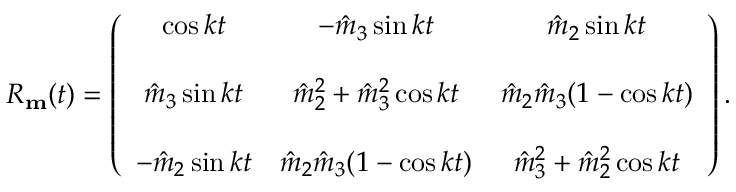<formula> <loc_0><loc_0><loc_500><loc_500>\begin{array} { r } { R _ { m } ( t ) = \left ( \begin{array} { c c c } { \cos k t } & { - \hat { m } _ { 3 } \sin k t } & { \hat { m } _ { 2 } \sin k t } \\ { \hat { m } _ { 3 } \sin k t } & { \hat { m } _ { 2 } ^ { 2 } + \hat { m } _ { 3 } ^ { 2 } \cos k t } & { \hat { m } _ { 2 } \hat { m } _ { 3 } ( 1 - \cos k t ) } \\ { - \hat { m } _ { 2 } \sin k t } & { \hat { m } _ { 2 } \hat { m } _ { 3 } ( 1 - \cos k t ) } & { \hat { m } _ { 3 } ^ { 2 } + \hat { m } _ { 2 } ^ { 2 } \cos k t } \end{array} \right ) . } \end{array}</formula> 